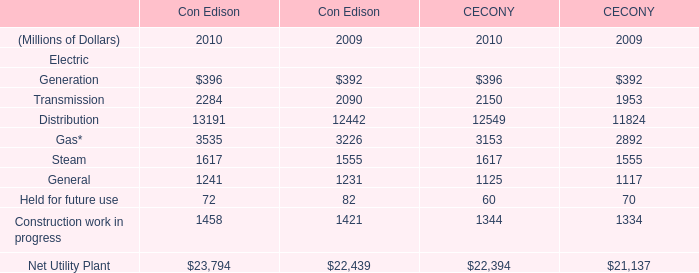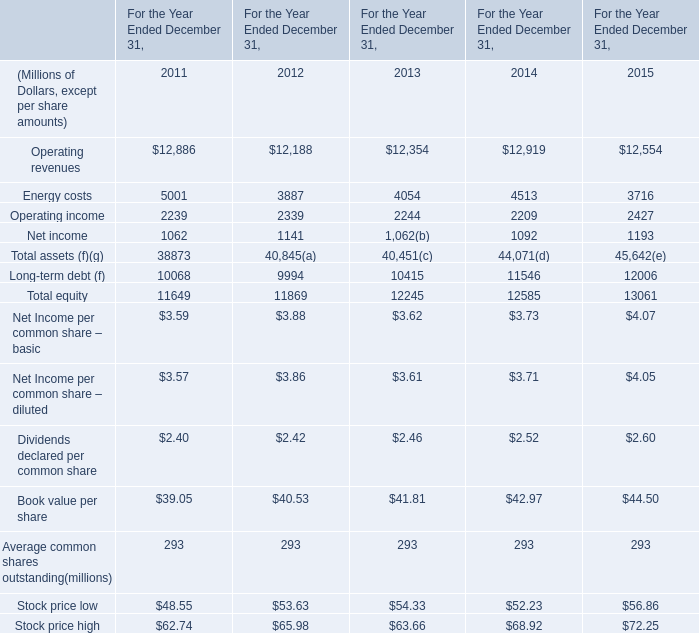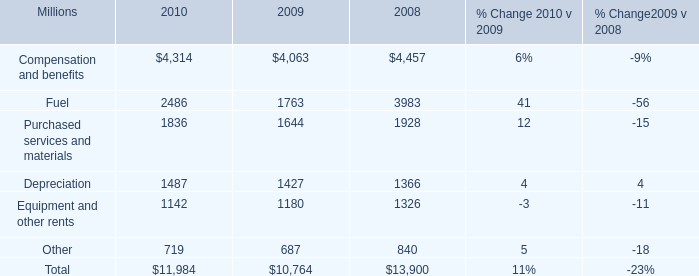In the year with largest amount of Operating income, what's the increasing rate of Operating revenues? 
Computations: ((12554 - 12919) / 12919)
Answer: -0.02825. 